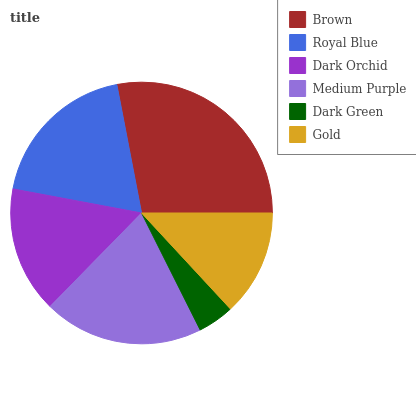Is Dark Green the minimum?
Answer yes or no. Yes. Is Brown the maximum?
Answer yes or no. Yes. Is Royal Blue the minimum?
Answer yes or no. No. Is Royal Blue the maximum?
Answer yes or no. No. Is Brown greater than Royal Blue?
Answer yes or no. Yes. Is Royal Blue less than Brown?
Answer yes or no. Yes. Is Royal Blue greater than Brown?
Answer yes or no. No. Is Brown less than Royal Blue?
Answer yes or no. No. Is Royal Blue the high median?
Answer yes or no. Yes. Is Dark Orchid the low median?
Answer yes or no. Yes. Is Dark Green the high median?
Answer yes or no. No. Is Dark Green the low median?
Answer yes or no. No. 